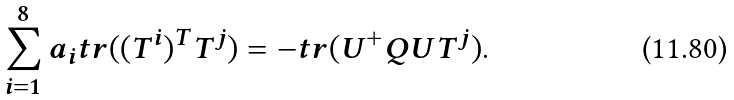Convert formula to latex. <formula><loc_0><loc_0><loc_500><loc_500>\sum _ { i = 1 } ^ { 8 } a _ { i } t r ( ( T ^ { i } ) ^ { T } T ^ { j } ) = - t r ( U ^ { + } Q U T ^ { j } ) .</formula> 